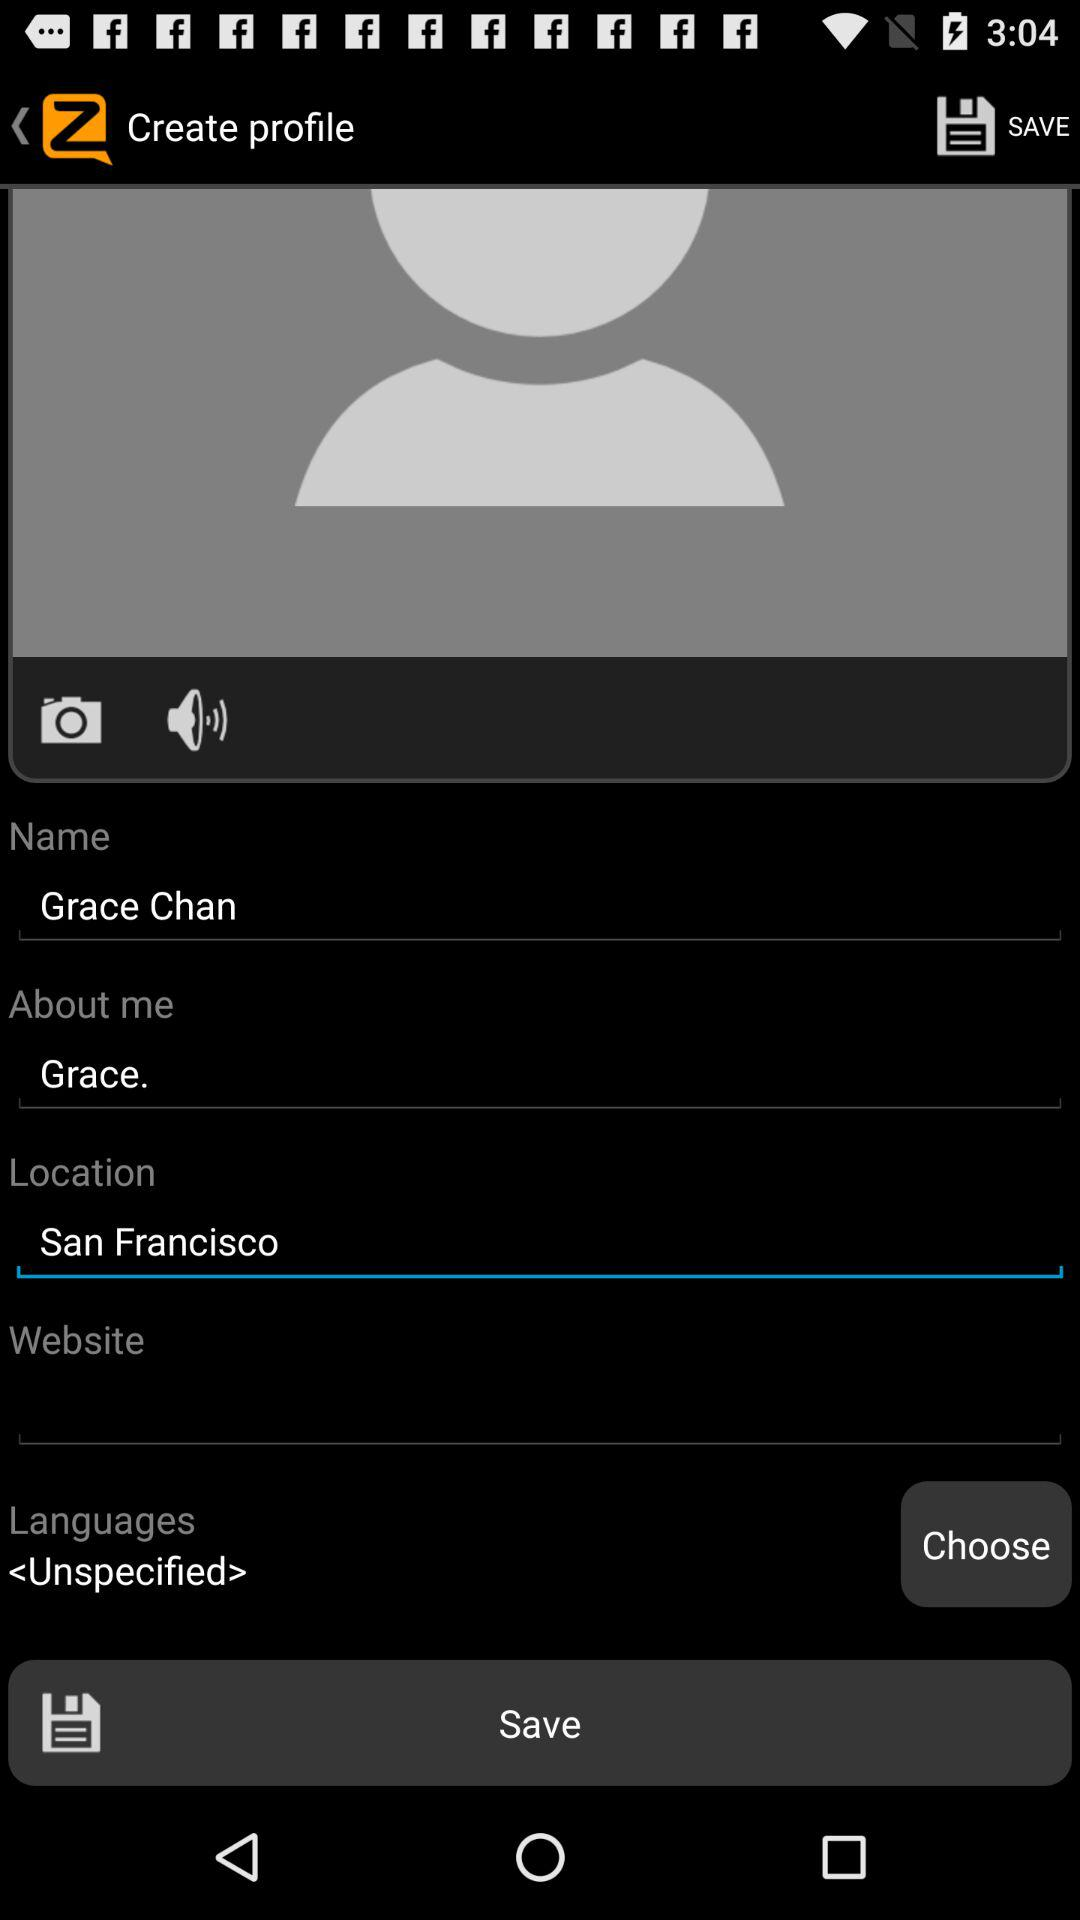What is the name? The name is Grace Chan. 